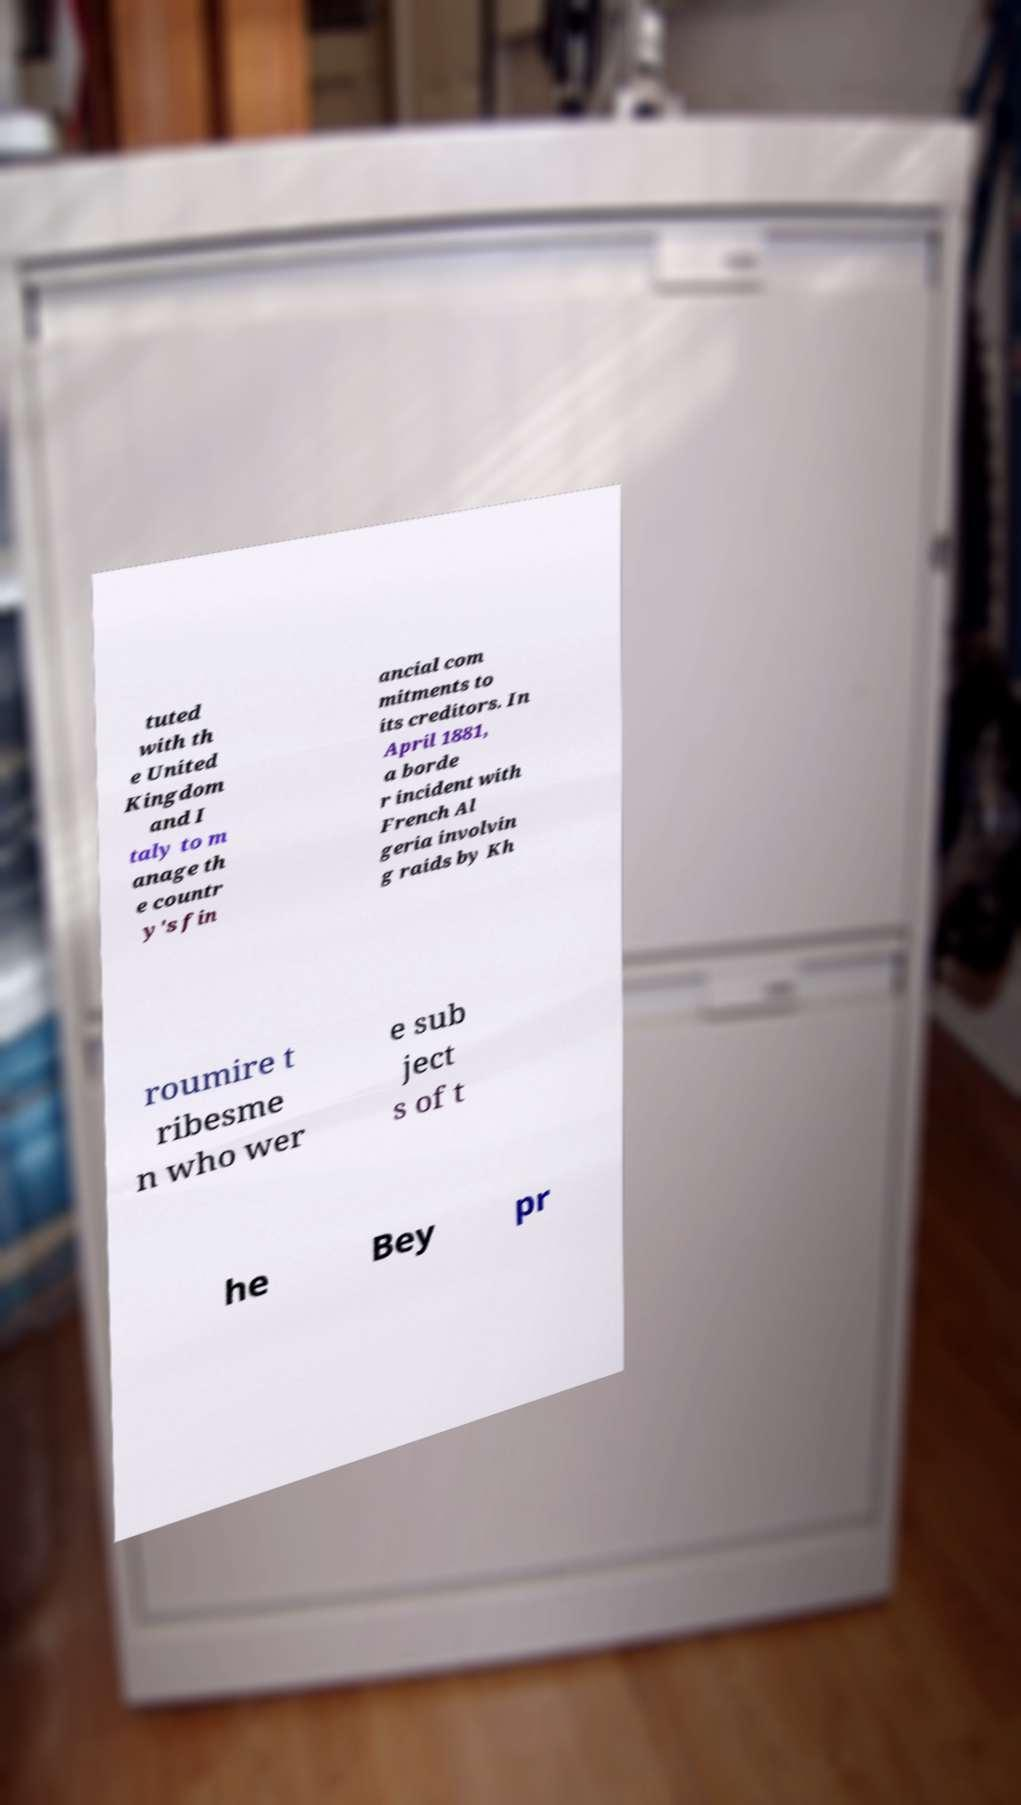Can you accurately transcribe the text from the provided image for me? tuted with th e United Kingdom and I taly to m anage th e countr y's fin ancial com mitments to its creditors. In April 1881, a borde r incident with French Al geria involvin g raids by Kh roumire t ribesme n who wer e sub ject s of t he Bey pr 